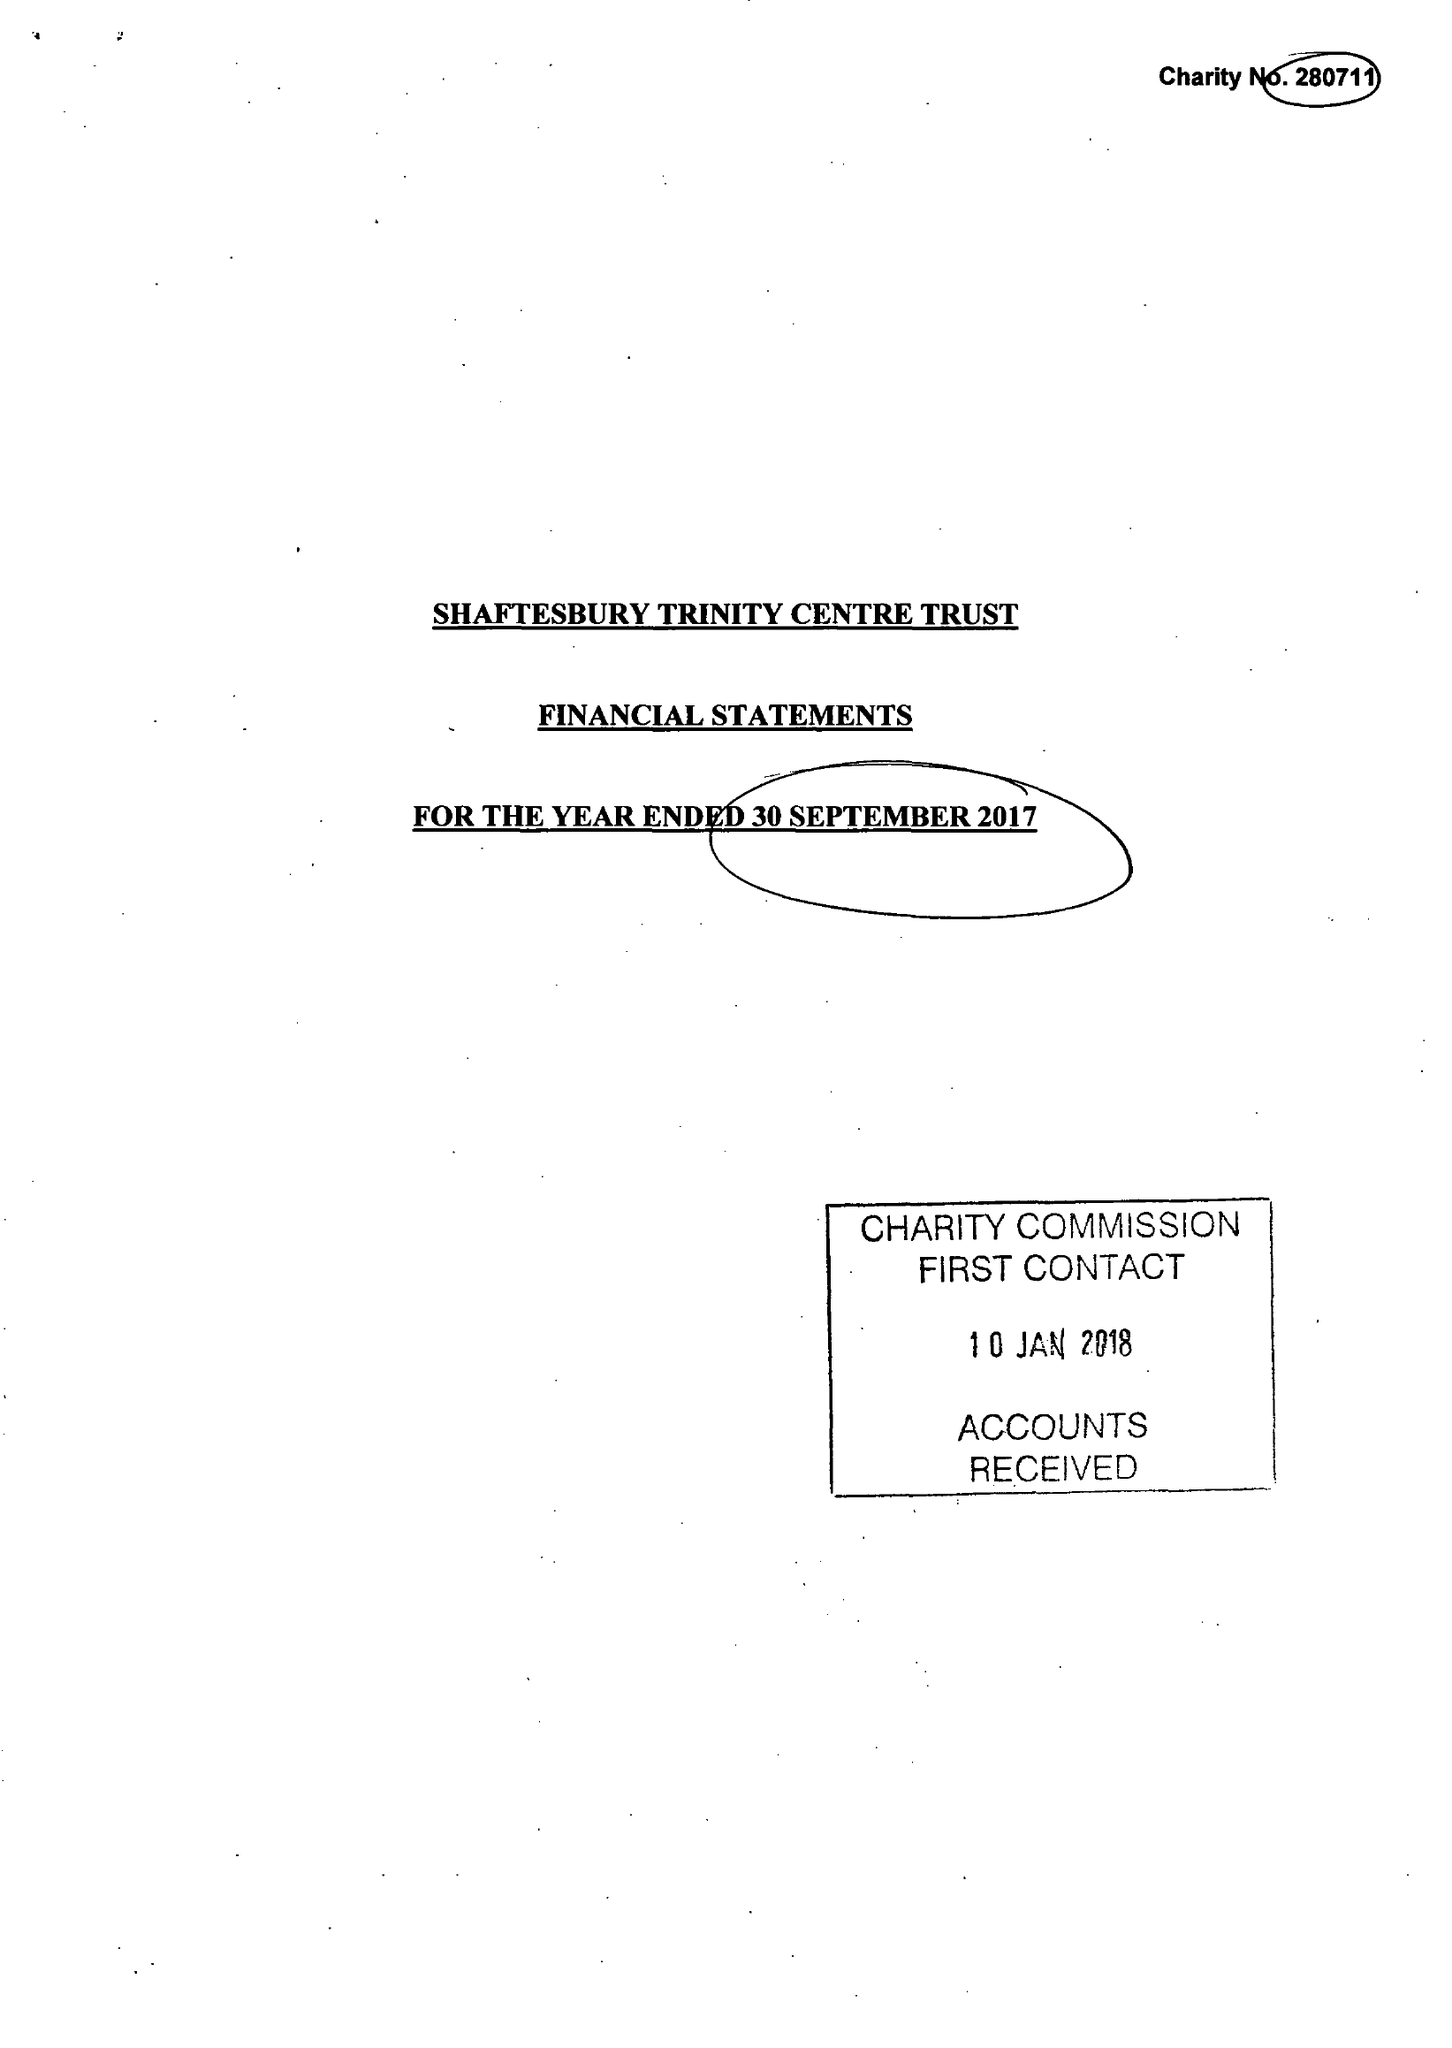What is the value for the report_date?
Answer the question using a single word or phrase. 2017-09-30 